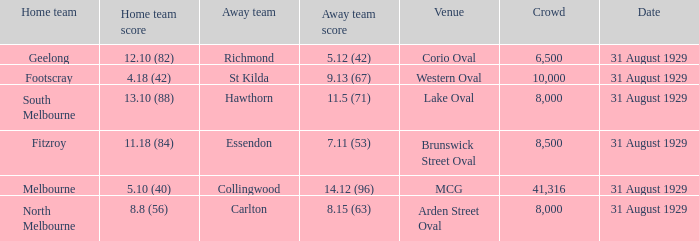What is the largest crowd when the away team is Hawthorn? 8000.0. Help me parse the entirety of this table. {'header': ['Home team', 'Home team score', 'Away team', 'Away team score', 'Venue', 'Crowd', 'Date'], 'rows': [['Geelong', '12.10 (82)', 'Richmond', '5.12 (42)', 'Corio Oval', '6,500', '31 August 1929'], ['Footscray', '4.18 (42)', 'St Kilda', '9.13 (67)', 'Western Oval', '10,000', '31 August 1929'], ['South Melbourne', '13.10 (88)', 'Hawthorn', '11.5 (71)', 'Lake Oval', '8,000', '31 August 1929'], ['Fitzroy', '11.18 (84)', 'Essendon', '7.11 (53)', 'Brunswick Street Oval', '8,500', '31 August 1929'], ['Melbourne', '5.10 (40)', 'Collingwood', '14.12 (96)', 'MCG', '41,316', '31 August 1929'], ['North Melbourne', '8.8 (56)', 'Carlton', '8.15 (63)', 'Arden Street Oval', '8,000', '31 August 1929']]} 